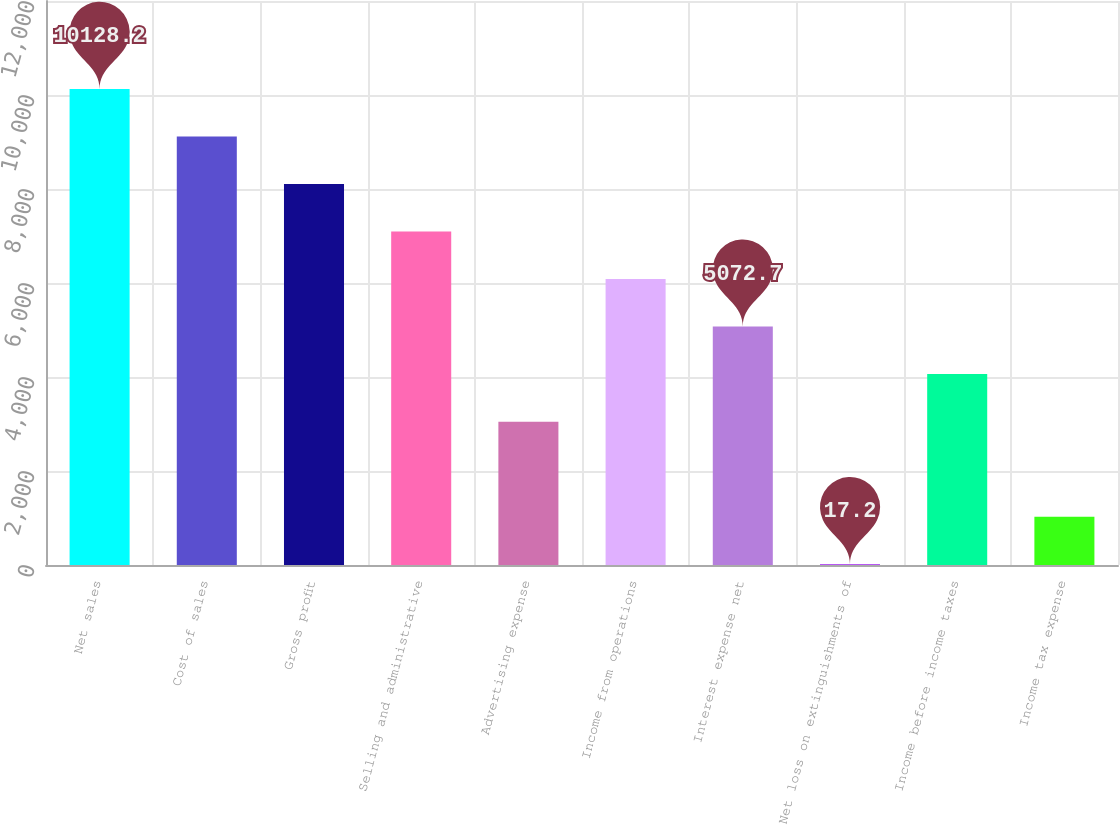Convert chart to OTSL. <chart><loc_0><loc_0><loc_500><loc_500><bar_chart><fcel>Net sales<fcel>Cost of sales<fcel>Gross profit<fcel>Selling and administrative<fcel>Advertising expense<fcel>Income from operations<fcel>Interest expense net<fcel>Net loss on extinguishments of<fcel>Income before income taxes<fcel>Income tax expense<nl><fcel>10128.2<fcel>9117.1<fcel>8106<fcel>7094.9<fcel>3050.5<fcel>6083.8<fcel>5072.7<fcel>17.2<fcel>4061.6<fcel>1028.3<nl></chart> 